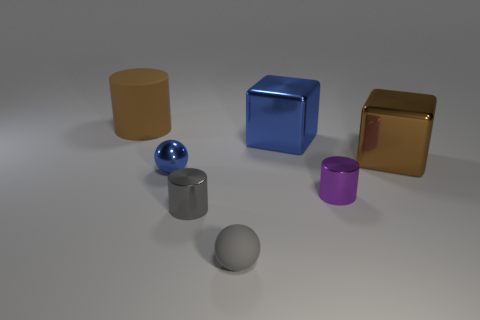Are there an equal number of big cubes to the right of the brown block and cyan cylinders?
Your answer should be very brief. Yes. What shape is the thing that is the same color as the matte ball?
Make the answer very short. Cylinder. How many purple things are the same size as the blue cube?
Offer a terse response. 0. There is a gray ball; how many blue metallic objects are to the left of it?
Your response must be concise. 1. The big thing that is on the left side of the tiny ball to the left of the small rubber ball is made of what material?
Your answer should be very brief. Rubber. Are there any cylinders of the same color as the metal sphere?
Make the answer very short. No. The sphere that is the same material as the tiny gray cylinder is what size?
Provide a short and direct response. Small. Is there any other thing of the same color as the tiny rubber thing?
Offer a terse response. Yes. The cylinder that is behind the small blue metal sphere is what color?
Keep it short and to the point. Brown. There is a metal block on the left side of the big metal thing that is on the right side of the large blue metallic object; are there any blue metallic objects that are in front of it?
Offer a very short reply. Yes. 